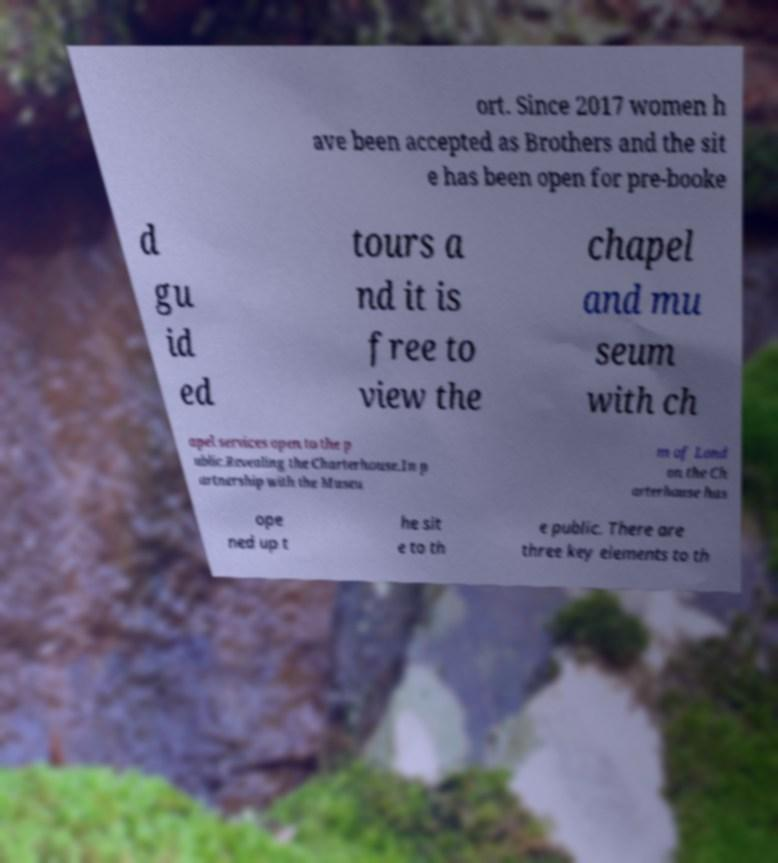For documentation purposes, I need the text within this image transcribed. Could you provide that? ort. Since 2017 women h ave been accepted as Brothers and the sit e has been open for pre-booke d gu id ed tours a nd it is free to view the chapel and mu seum with ch apel services open to the p ublic.Revealing the Charterhouse.In p artnership with the Museu m of Lond on the Ch arterhouse has ope ned up t he sit e to th e public. There are three key elements to th 